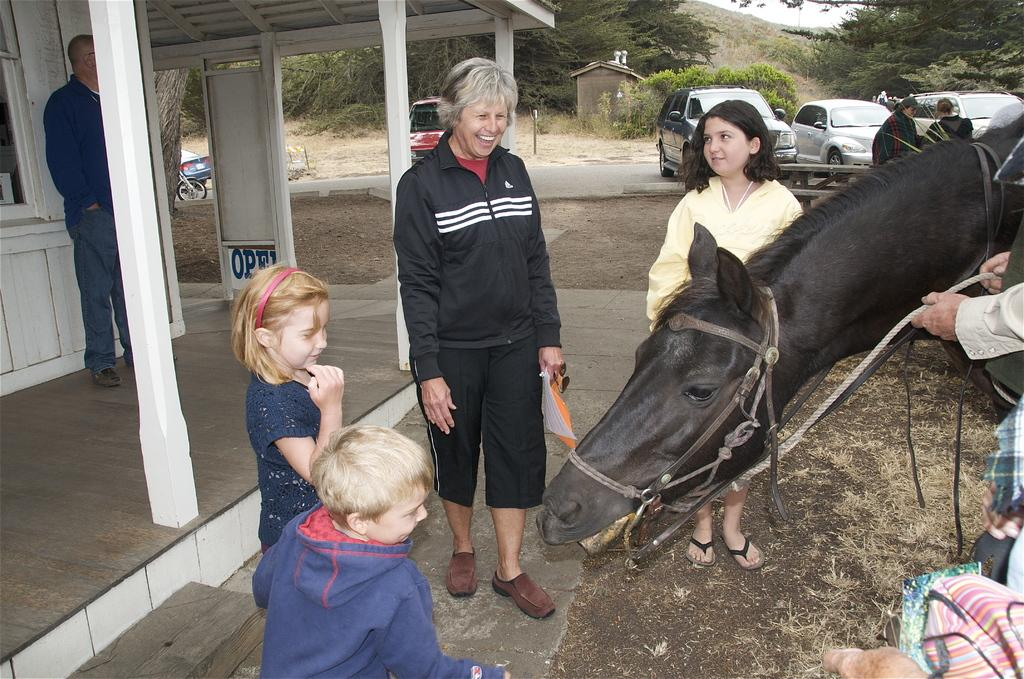Who is present in the image? There is a woman in the image. What is the woman doing in the image? The woman is standing and smiling. Are there any other people in the image? Yes, there are kids in the image. What are the kids doing in the image? The kids are standing. What animal can be seen in the image? There is a horse in the image. What can be seen in the background of the image? Cars are visible in the background of the image. What type of church can be seen in the image? There is no church present in the image. What season is depicted in the image? The provided facts do not mention any specific season or time of year. 